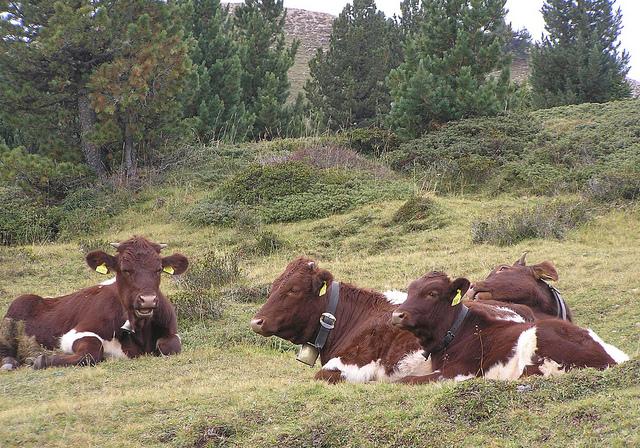How many cows are there?
Write a very short answer. 4. Is there a fence?
Write a very short answer. No. What are the cows doing?
Short answer required. Laying down. 